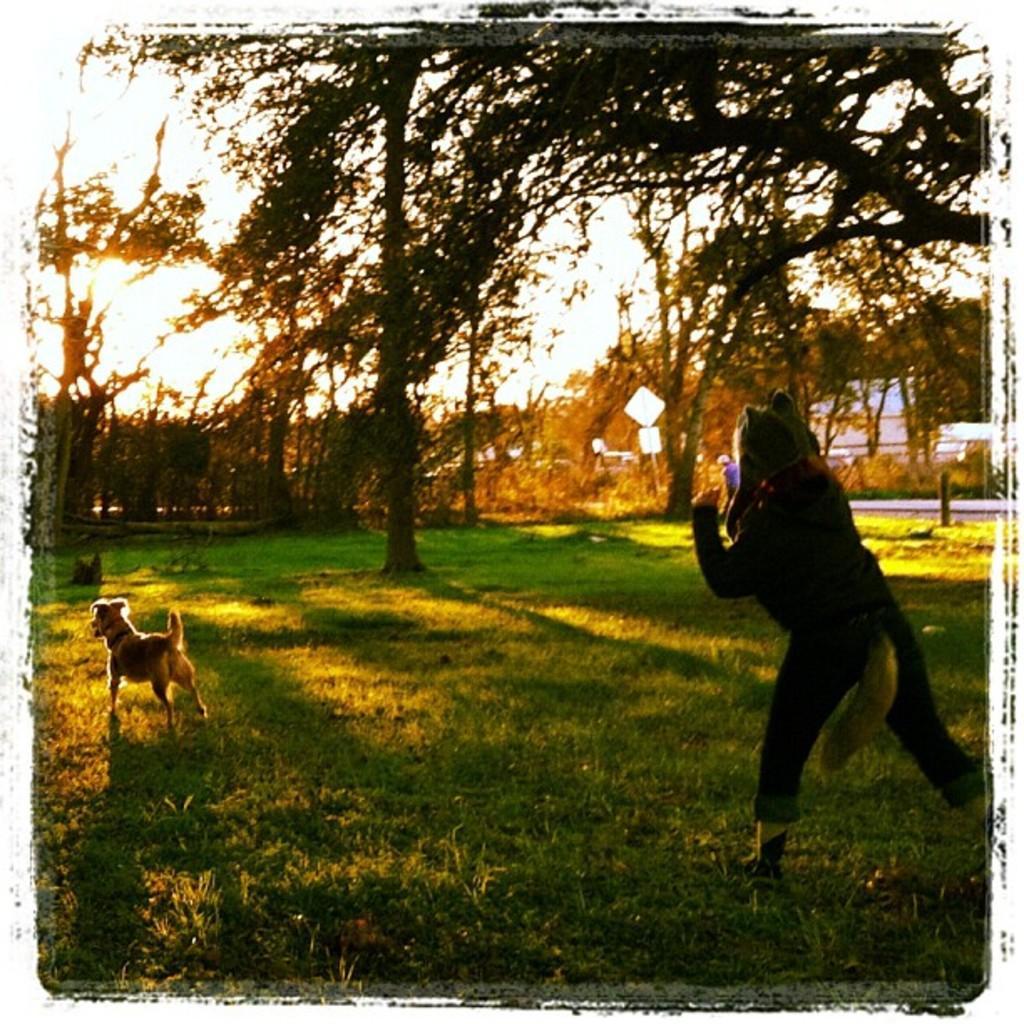Please provide a concise description of this image. In this image there is the sky, there are trees, there is tree truncated towards the top of the image, there is the grass, there is a pole, there are boards, there is a dog, there is a person holding an object. 